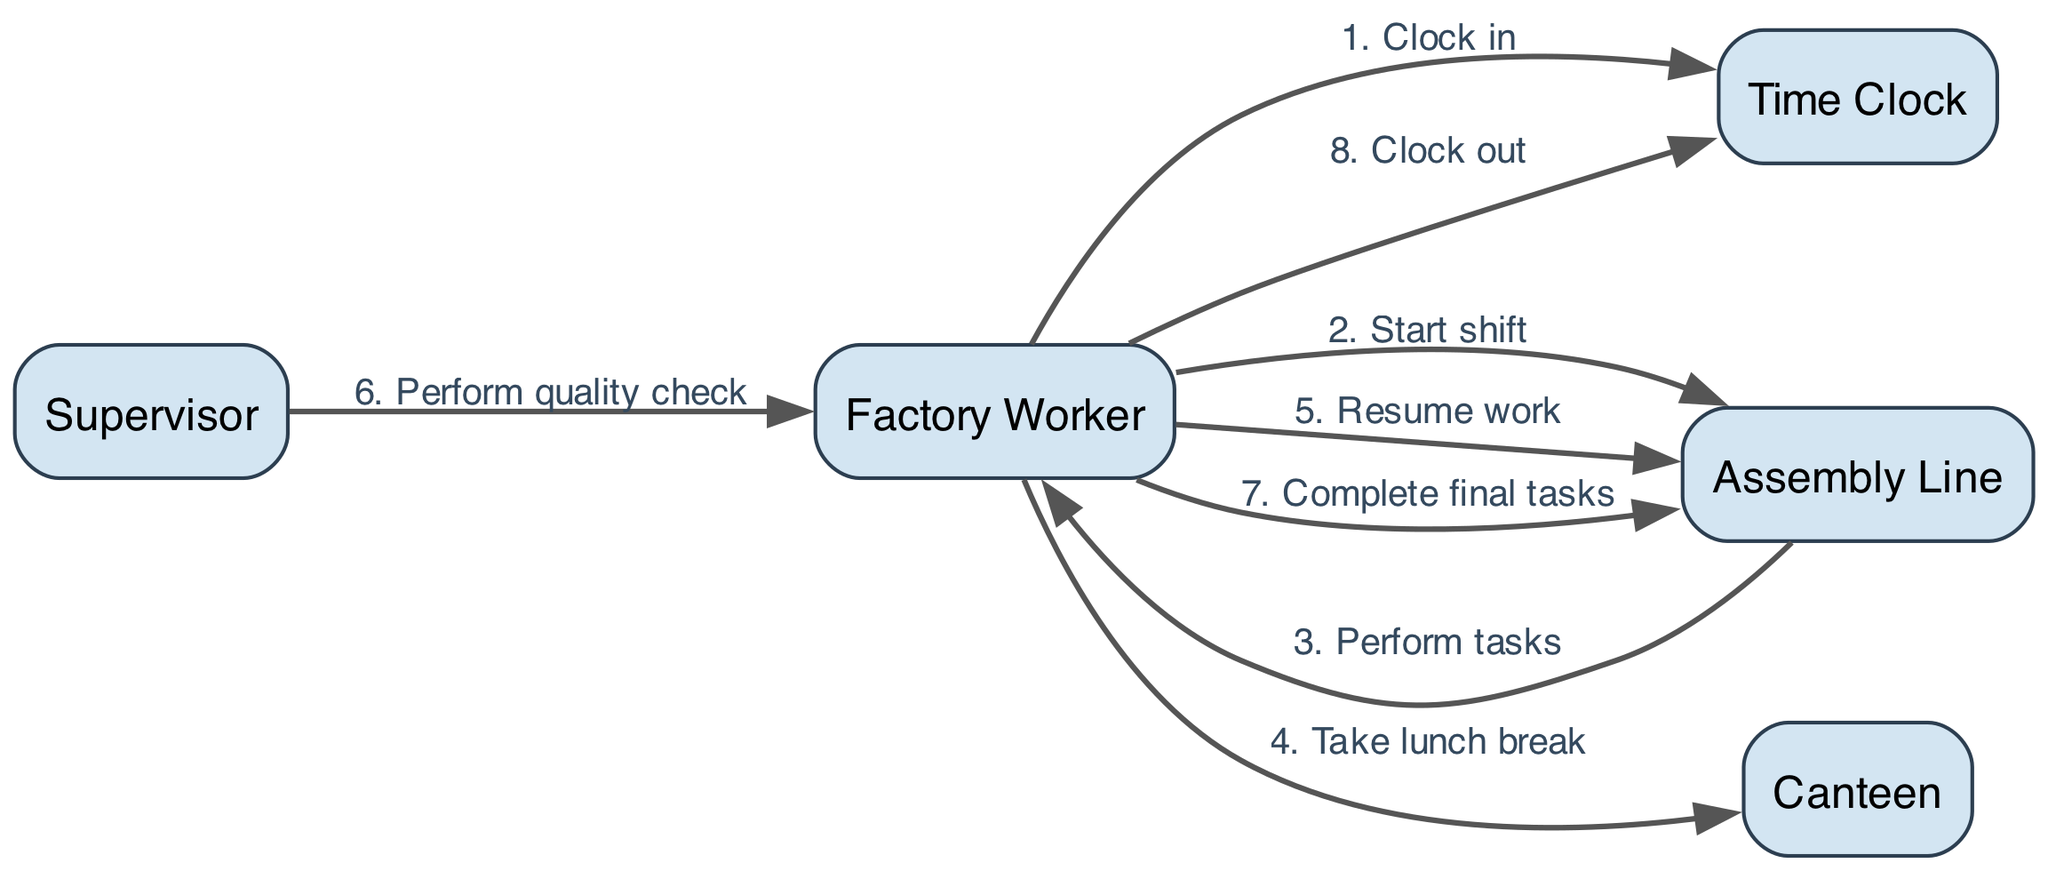What is the first action a Factory Worker takes? The first action in the diagram is from the Factory Worker to the Time Clock, labeled "Clock in." Therefore, the concise answer is the action "Clock in."
Answer: Clock in How many actors are represented in the diagram? The diagram lists five distinct actors: Factory Worker, Time Clock, Assembly Line, Canteen, and Supervisor. Hence, the count of actors is five.
Answer: 5 What action follows after "Take lunch break"? After the "Take lunch break" action from the Factory Worker, the next action is "Resume work" where the Factory Worker returns to the Assembly Line. Therefore, the action that follows is "Resume work."
Answer: Resume work Who performs the quality check? The quality check is performed by the Supervisor on the Factory Worker as depicted in the diagram, making the concise answer "Supervisor."
Answer: Supervisor What are the last two actions performed by the Factory Worker? The last two actions in the sequence for the Factory Worker are "Complete final tasks" (before clocking out) and then "Clock out." Thus, the last actions are "Complete final tasks" and "Clock out."
Answer: Complete final tasks, Clock out Which actor does the Factory Worker interact with after starting their shift? Immediately after starting their shift, the Factory Worker interacts with the Assembly Line to perform tasks. Therefore, the main actor involved at this step is the Assembly Line.
Answer: Assembly Line What is the action taken by the Factory Worker immediately before clocking out? Before clocking out, the Factory Worker completes their final tasks on the Assembly Line. So, the action immediately prior to clocking out is "Complete final tasks."
Answer: Complete final tasks How many transitions occur between the Factory Worker and the Assembly Line during a typical workday? The transitions consist of four distinct connections: starting work, performing tasks, resuming work after lunch, and completing final tasks. Thus, the total transitions are four.
Answer: 4 What is the relationship between the supervisor and the factory worker in the diagram? The relationship is characterized by a directed action where the Supervisor performs a quality check on the Factory Worker, suggesting oversight and responsibility for quality control. Hence, the relationship is about quality control.
Answer: Quality control 